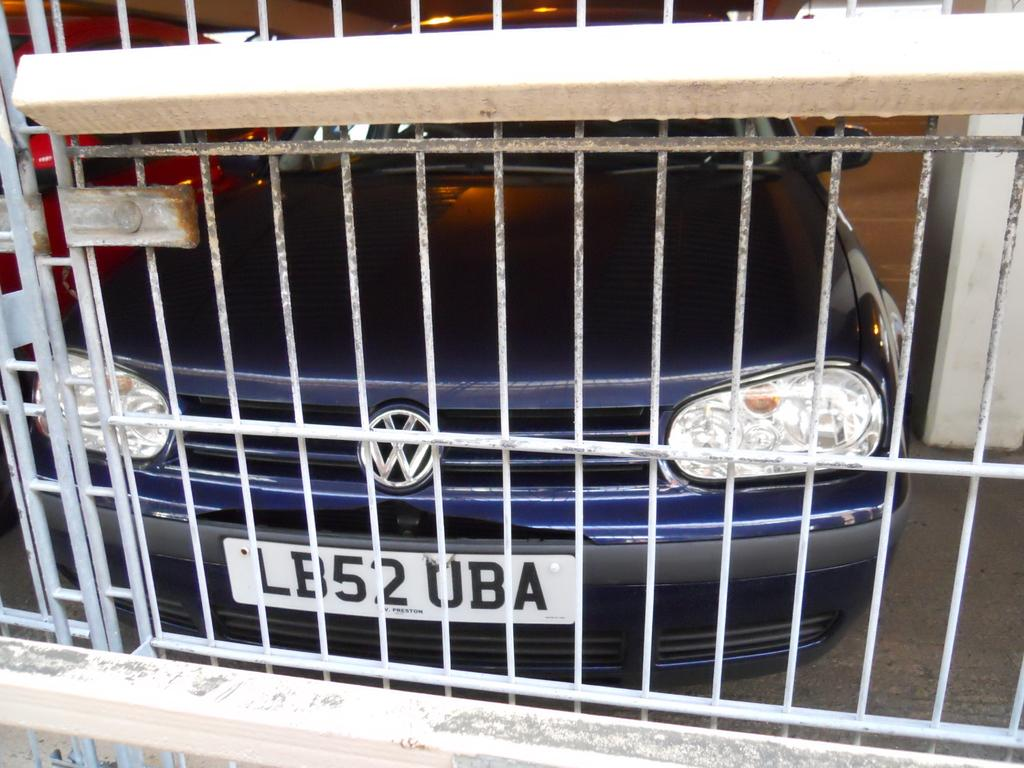What structure can be seen in the image? There is a gate in the image. What is located behind the gate in the image? There are two cars visible behind the gate in the image. What type of tax is being collected at the gate in the image? There is no indication of any tax being collected at the gate in the image. 